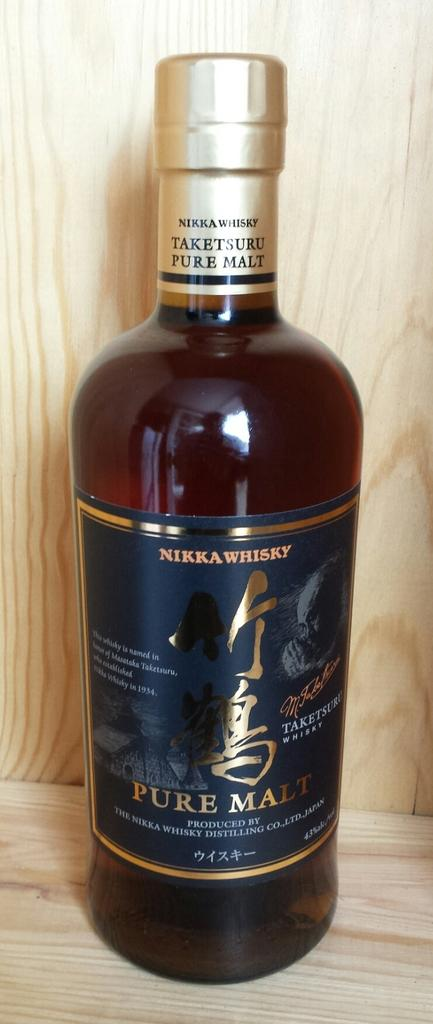<image>
Give a short and clear explanation of the subsequent image. A large bottle of Taketsuru pure malt Nikka Whiskey. 